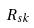<formula> <loc_0><loc_0><loc_500><loc_500>R _ { s k }</formula> 